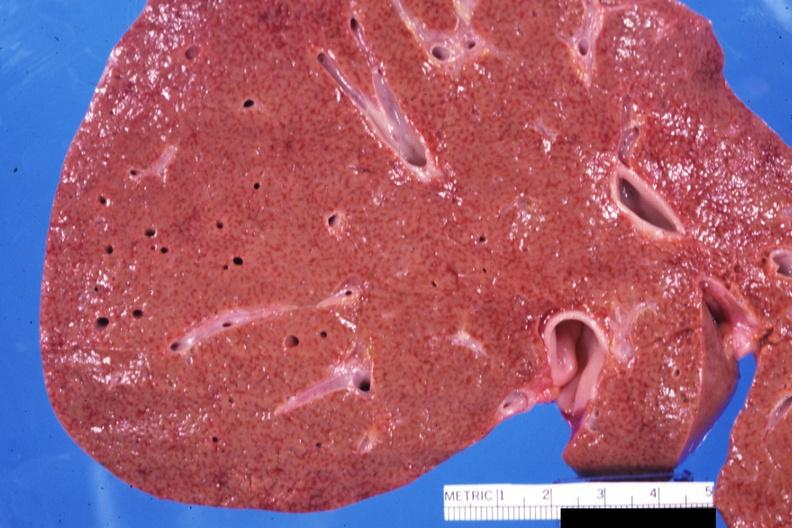what does this image show?
Answer the question using a single word or phrase. Close-up view of early micronodular cirrhosis quite good 